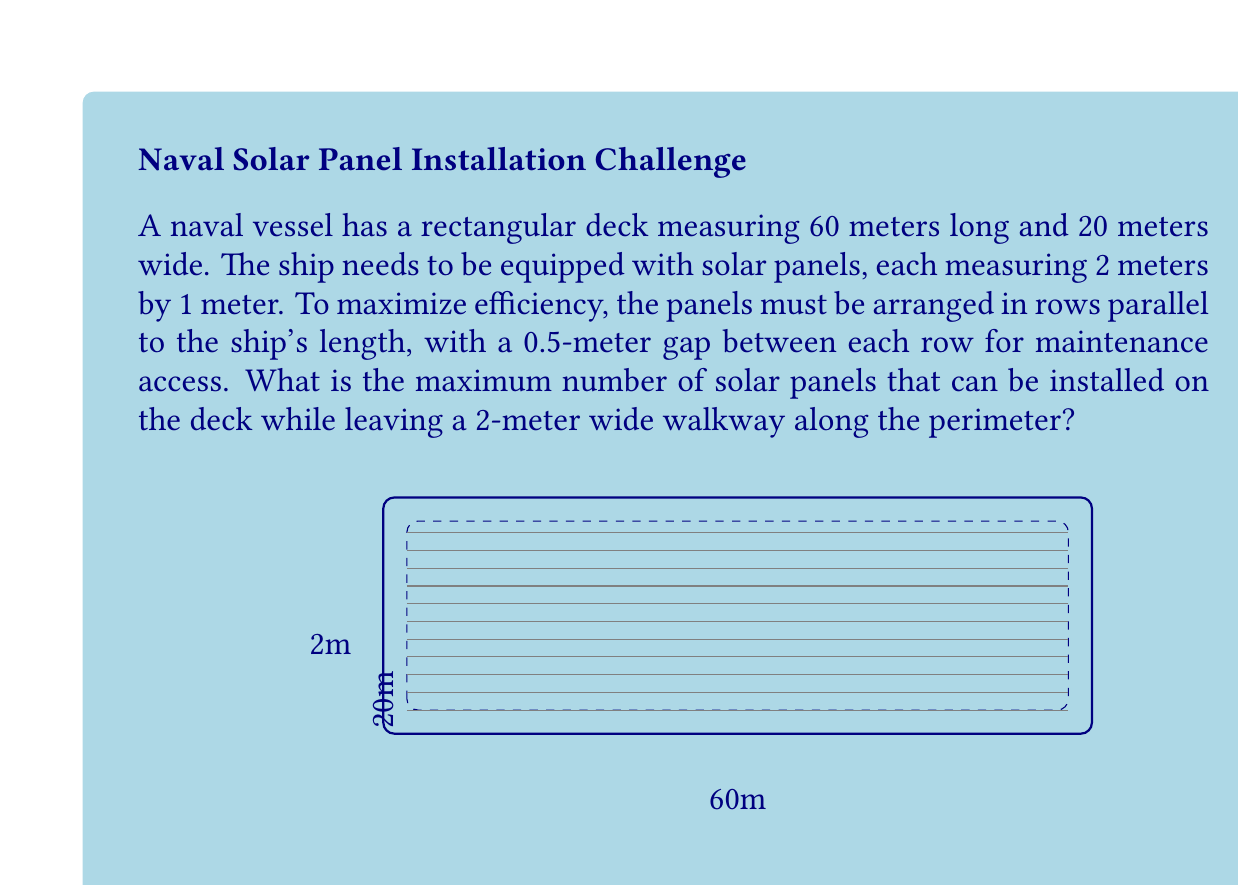Provide a solution to this math problem. Let's approach this problem step by step:

1) First, we need to calculate the available area for solar panels:
   - Total deck width: 20 meters
   - Minus walkway on both sides: 20 - (2 × 2) = 16 meters
   - Available length: 60 - (2 × 2) = 56 meters

2) Now, let's calculate how many rows of panels we can fit:
   - Each panel is 1 meter wide
   - We need a 0.5-meter gap between rows
   - So each row (including gap) takes up 1.5 meters
   - Number of rows = $\lfloor \frac{16}{1.5} \rfloor = 10$ rows
   (We use the floor function as we can't have a partial row)

3) For each row:
   - Available length: 56 meters
   - Each panel is 2 meters long
   - Number of panels per row = $\lfloor \frac{56}{2} \rfloor = 28$ panels

4) Total number of panels:
   $$ \text{Total panels} = \text{Number of rows} \times \text{Panels per row} $$
   $$ \text{Total panels} = 10 \times 28 = 280 \text{ panels} $$

Therefore, the maximum number of solar panels that can be installed is 280.
Answer: 280 panels 